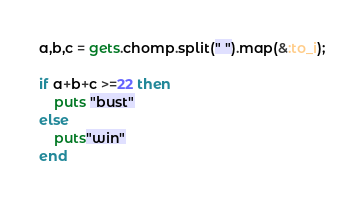<code> <loc_0><loc_0><loc_500><loc_500><_Ruby_>a,b,c = gets.chomp.split(" ").map(&:to_i);

if a+b+c >=22 then
	puts "bust"
else
	puts"win"
end
</code> 